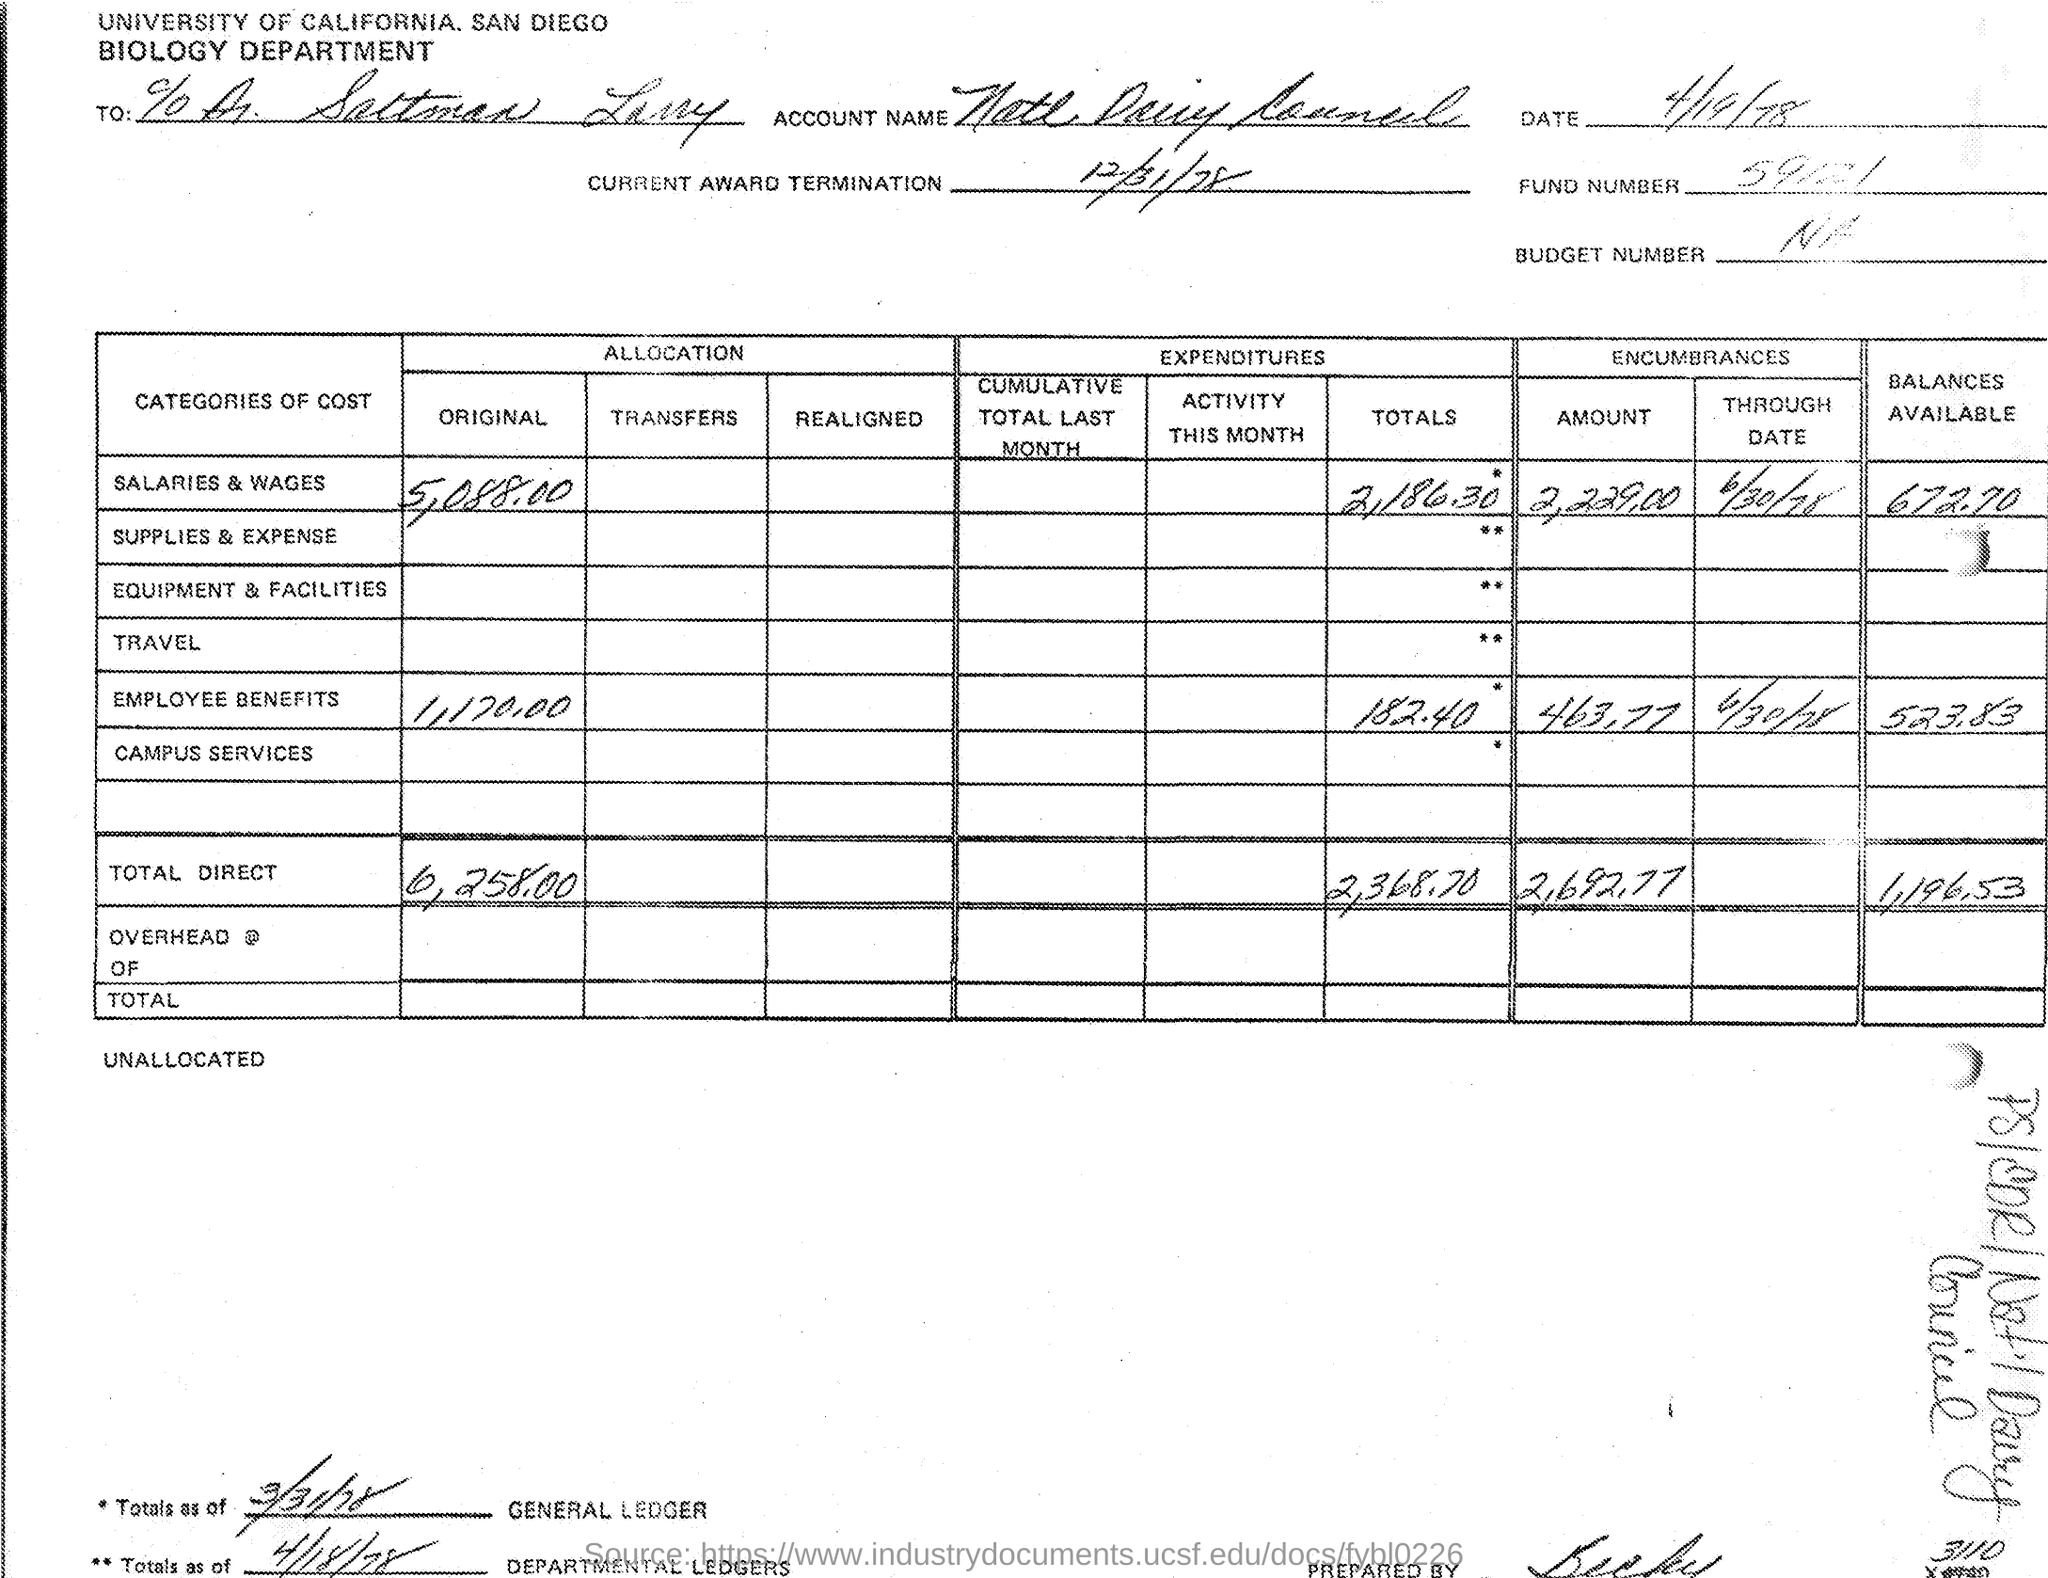List a handful of essential elements in this visual. The Budget Number is not available as of now. The location of the Biology Department at the University of California, San Diego, is unknown. The document mentions the details of the Biology department. The fund number is 59121. The bill indicates that the date mentioned is April 19th, 1978. 